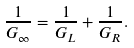Convert formula to latex. <formula><loc_0><loc_0><loc_500><loc_500>\frac { 1 } { G _ { \infty } } = \frac { 1 } { G _ { L } } + \frac { 1 } { G _ { R } } .</formula> 